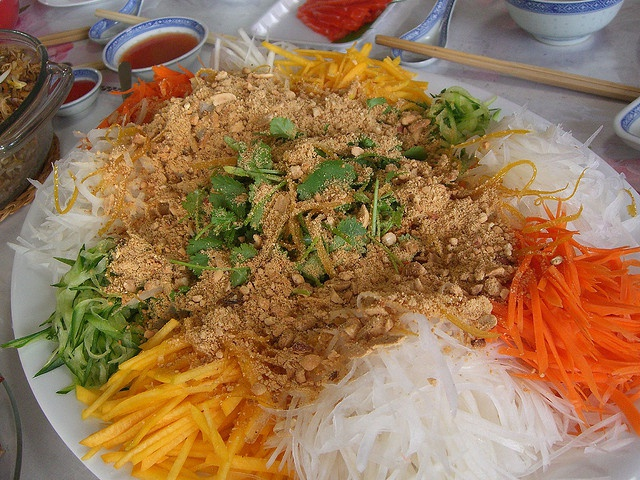Describe the objects in this image and their specific colors. I can see bowl in gray, maroon, and black tones, carrot in gray, red, and brown tones, bowl in gray, maroon, and darkgray tones, bowl in gray and darkgray tones, and spoon in gray and darkgray tones in this image. 